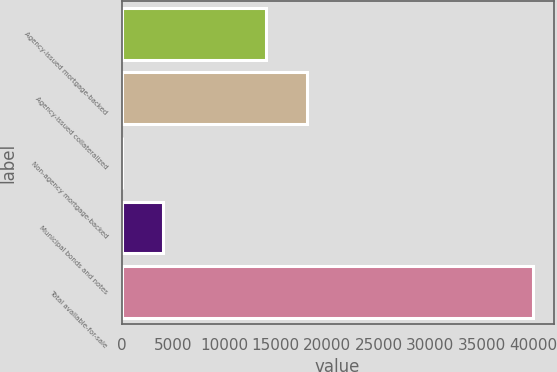Convert chart to OTSL. <chart><loc_0><loc_0><loc_500><loc_500><bar_chart><fcel>Agency-issued mortgage-backed<fcel>Agency-issued collateralized<fcel>Non-agency mortgage-backed<fcel>Municipal bonds and notes<fcel>Total available-for-sale<nl><fcel>14050<fcel>18046<fcel>48<fcel>4044<fcel>40008<nl></chart> 